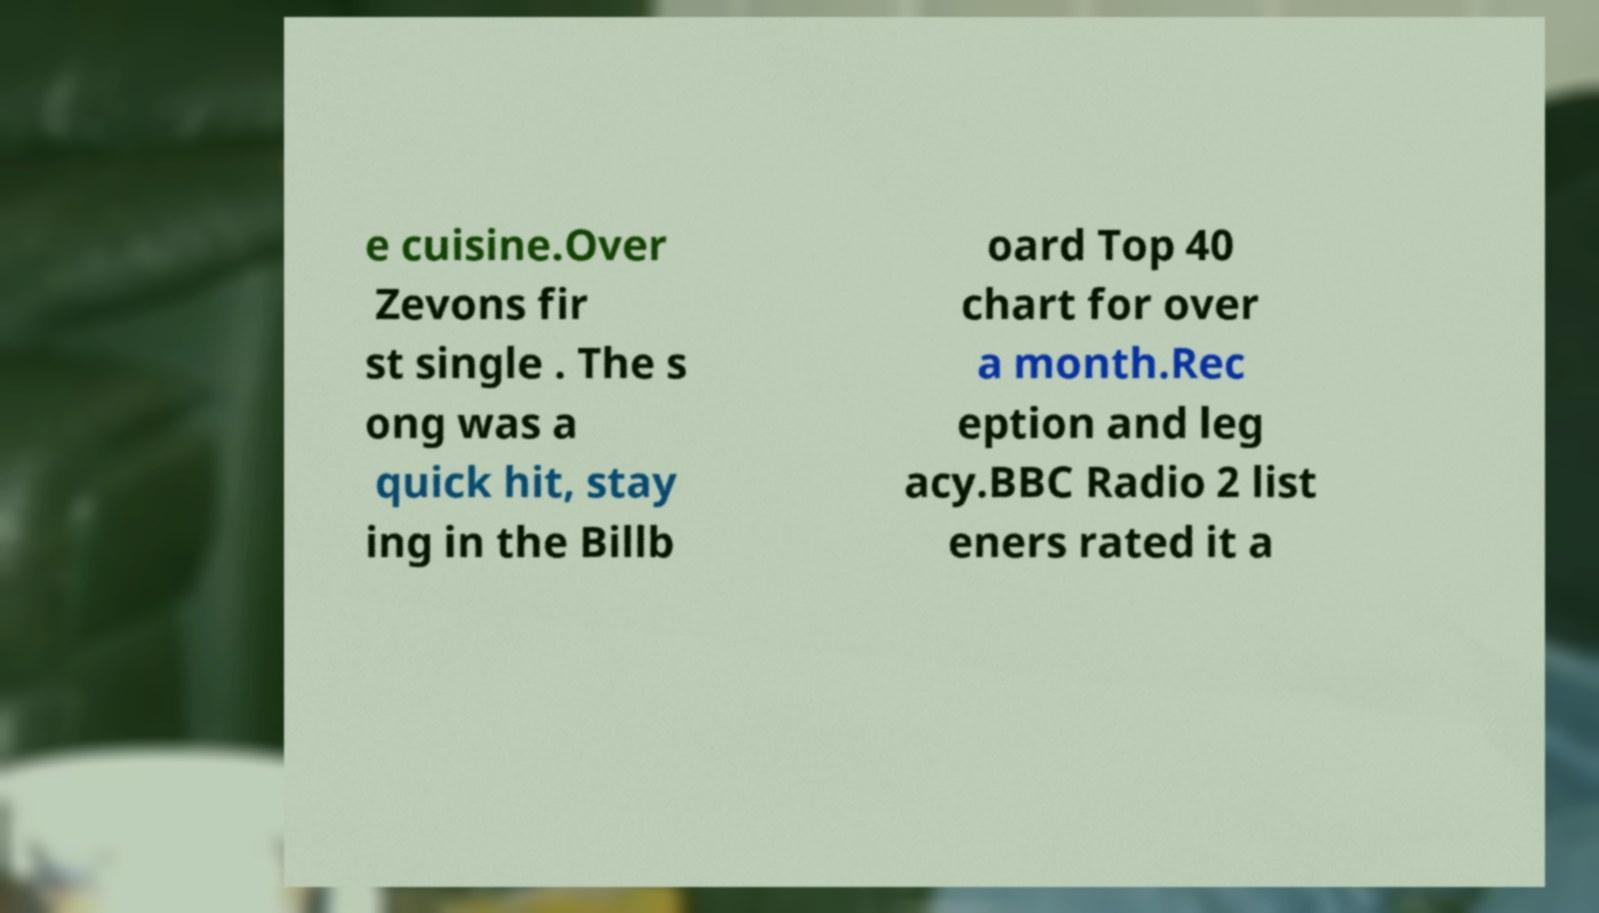Can you accurately transcribe the text from the provided image for me? e cuisine.Over Zevons fir st single . The s ong was a quick hit, stay ing in the Billb oard Top 40 chart for over a month.Rec eption and leg acy.BBC Radio 2 list eners rated it a 